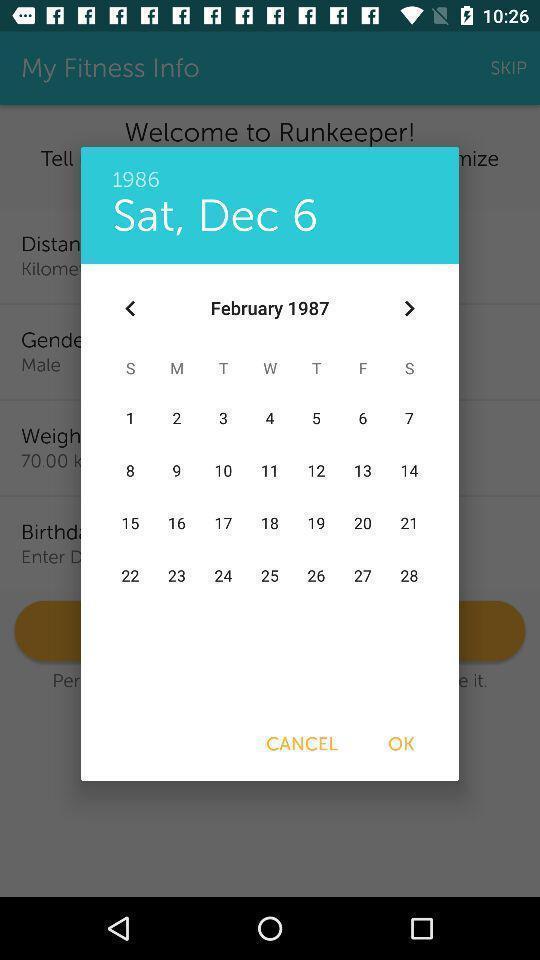Give me a narrative description of this picture. Pop up page for selecting a day in calendar. 